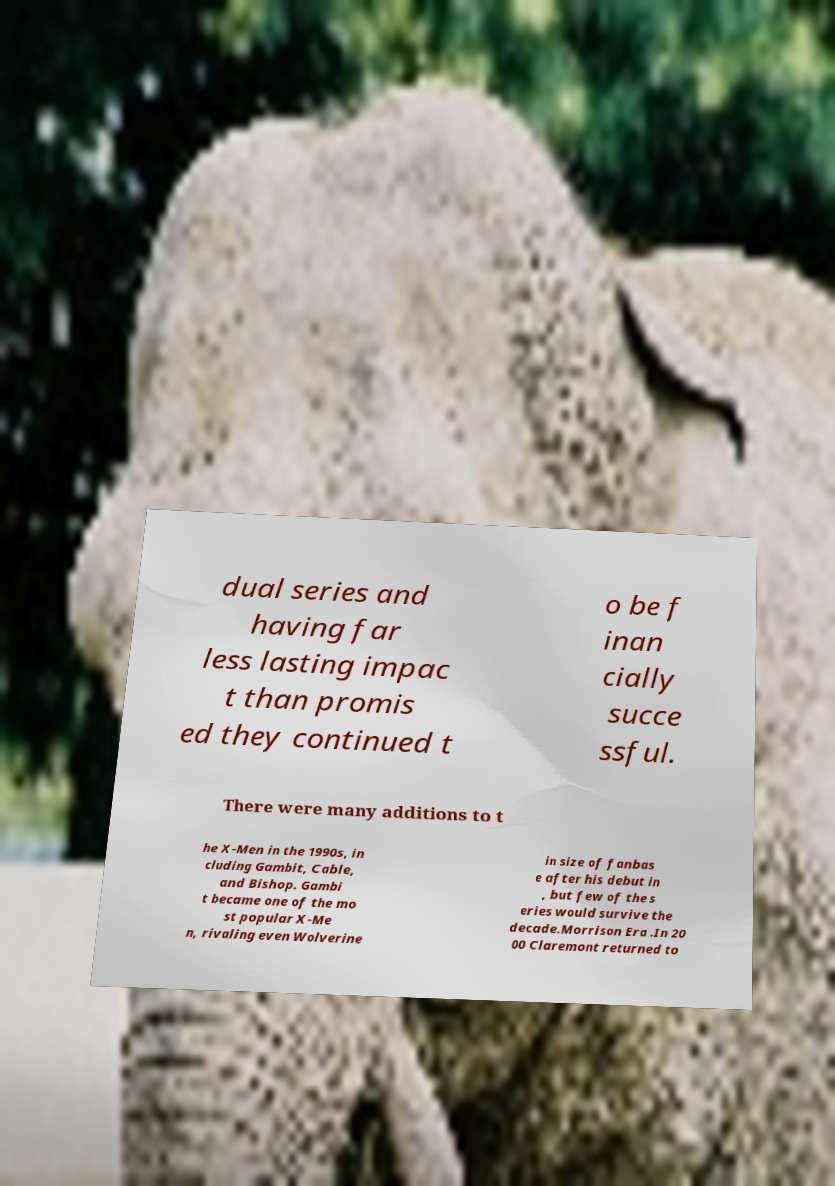Please identify and transcribe the text found in this image. dual series and having far less lasting impac t than promis ed they continued t o be f inan cially succe ssful. There were many additions to t he X-Men in the 1990s, in cluding Gambit, Cable, and Bishop. Gambi t became one of the mo st popular X-Me n, rivaling even Wolverine in size of fanbas e after his debut in , but few of the s eries would survive the decade.Morrison Era .In 20 00 Claremont returned to 